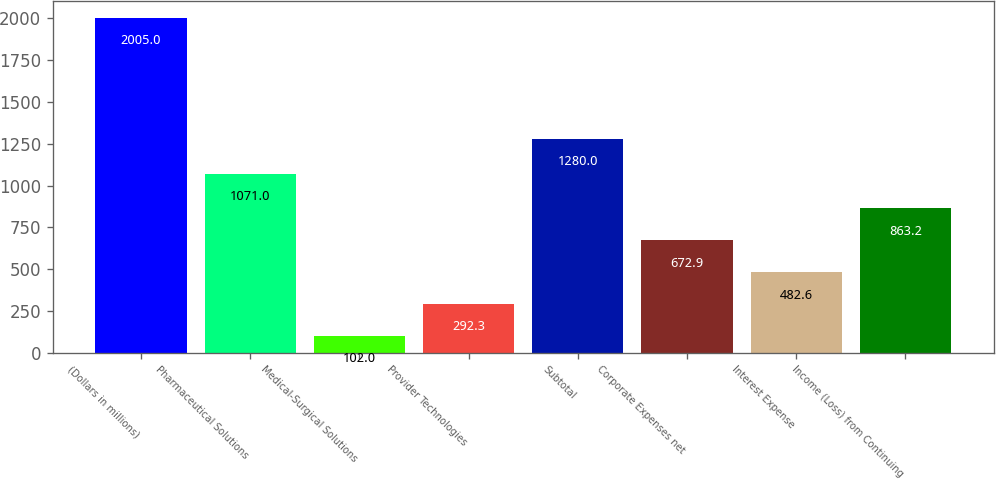<chart> <loc_0><loc_0><loc_500><loc_500><bar_chart><fcel>(Dollars in millions)<fcel>Pharmaceutical Solutions<fcel>Medical-Surgical Solutions<fcel>Provider Technologies<fcel>Subtotal<fcel>Corporate Expenses net<fcel>Interest Expense<fcel>Income (Loss) from Continuing<nl><fcel>2005<fcel>1071<fcel>102<fcel>292.3<fcel>1280<fcel>672.9<fcel>482.6<fcel>863.2<nl></chart> 